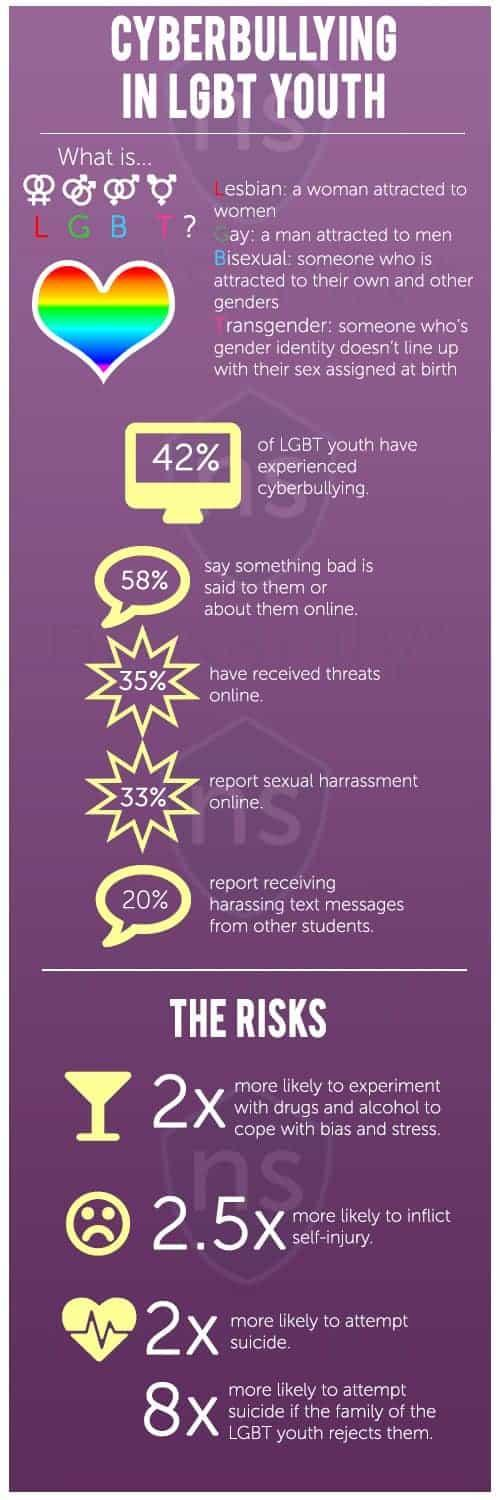What is G in LGBT?
Answer the question with a short phrase. Gay What does B in LGBT stand for? Bisexual What is the third risk mentioned? more likely to attempt suicide What is L in LGBT? Lesbian What did nearly one-thirds of LGBT youth report? sexual harrassment online What does T in LGBT stand for? Transgender What percentage of youth reported cyberbullying? 42% 